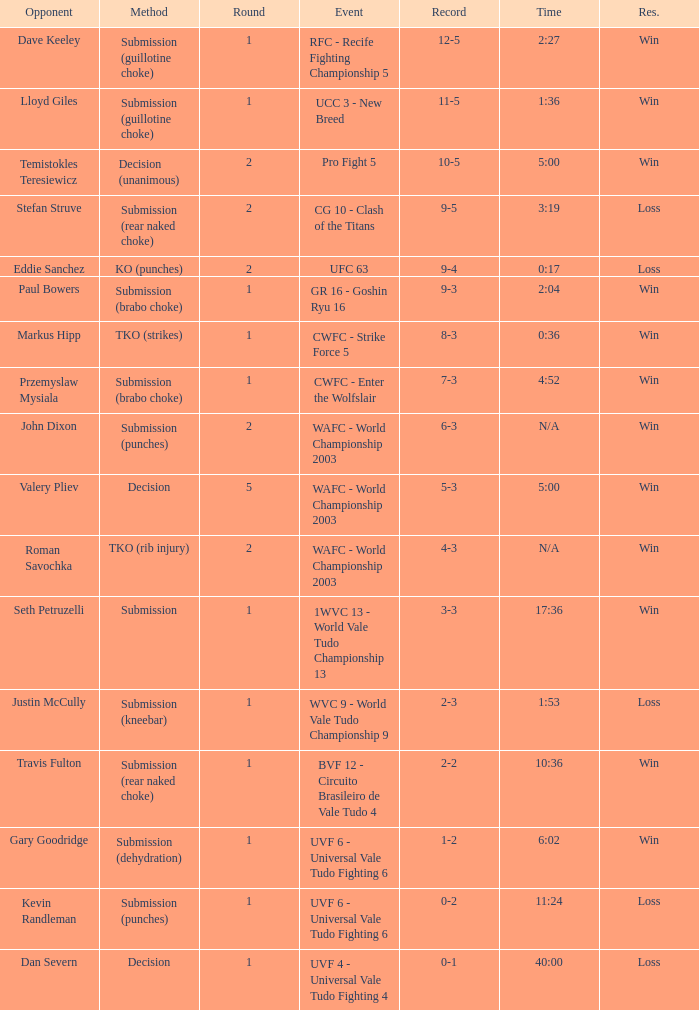What round has the highest Res loss, and a time of 40:00? 1.0. 